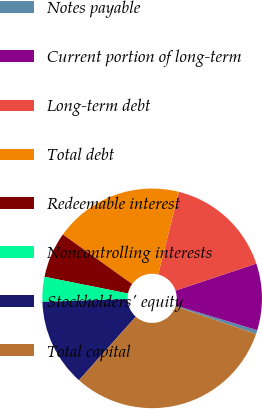Convert chart to OTSL. <chart><loc_0><loc_0><loc_500><loc_500><pie_chart><fcel>Notes payable<fcel>Current portion of long-term<fcel>Long-term debt<fcel>Total debt<fcel>Redeemable interest<fcel>Noncontrolling interests<fcel>Stockholders' equity<fcel>Total capital<nl><fcel>0.58%<fcel>9.81%<fcel>15.96%<fcel>19.04%<fcel>6.73%<fcel>3.66%<fcel>12.88%<fcel>31.34%<nl></chart> 